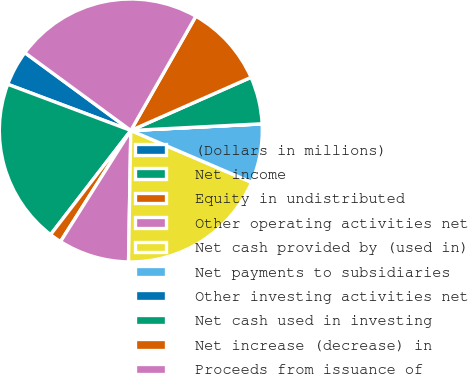Convert chart. <chart><loc_0><loc_0><loc_500><loc_500><pie_chart><fcel>(Dollars in millions)<fcel>Net income<fcel>Equity in undistributed<fcel>Other operating activities net<fcel>Net cash provided by (used in)<fcel>Net payments to subsidiaries<fcel>Other investing activities net<fcel>Net cash used in investing<fcel>Net increase (decrease) in<fcel>Proceeds from issuance of<nl><fcel>4.36%<fcel>20.27%<fcel>1.47%<fcel>8.7%<fcel>18.82%<fcel>7.25%<fcel>0.02%<fcel>5.81%<fcel>10.14%<fcel>23.16%<nl></chart> 